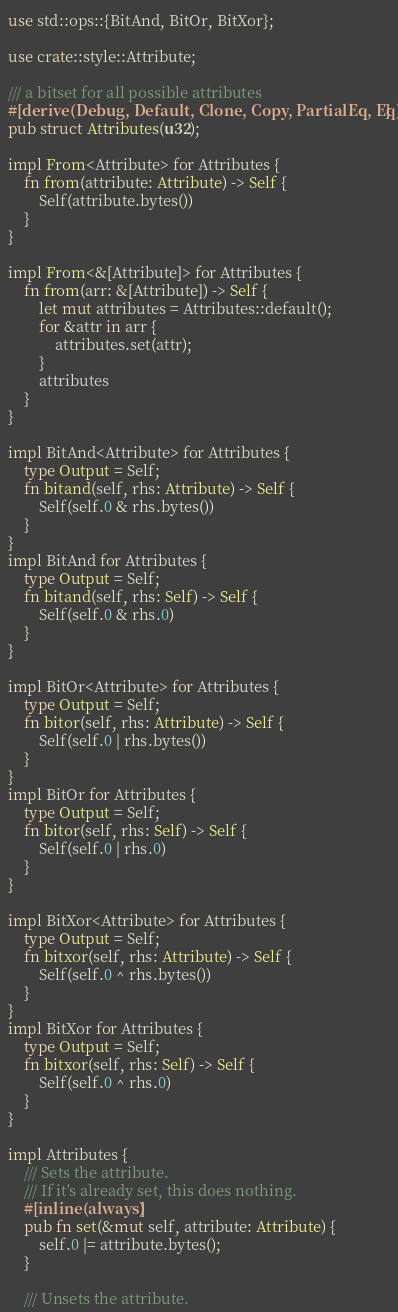<code> <loc_0><loc_0><loc_500><loc_500><_Rust_>use std::ops::{BitAnd, BitOr, BitXor};

use crate::style::Attribute;

/// a bitset for all possible attributes
#[derive(Debug, Default, Clone, Copy, PartialEq, Eq)]
pub struct Attributes(u32);

impl From<Attribute> for Attributes {
    fn from(attribute: Attribute) -> Self {
        Self(attribute.bytes())
    }
}

impl From<&[Attribute]> for Attributes {
    fn from(arr: &[Attribute]) -> Self {
        let mut attributes = Attributes::default();
        for &attr in arr {
            attributes.set(attr);
        }
        attributes
    }
}

impl BitAnd<Attribute> for Attributes {
    type Output = Self;
    fn bitand(self, rhs: Attribute) -> Self {
        Self(self.0 & rhs.bytes())
    }
}
impl BitAnd for Attributes {
    type Output = Self;
    fn bitand(self, rhs: Self) -> Self {
        Self(self.0 & rhs.0)
    }
}

impl BitOr<Attribute> for Attributes {
    type Output = Self;
    fn bitor(self, rhs: Attribute) -> Self {
        Self(self.0 | rhs.bytes())
    }
}
impl BitOr for Attributes {
    type Output = Self;
    fn bitor(self, rhs: Self) -> Self {
        Self(self.0 | rhs.0)
    }
}

impl BitXor<Attribute> for Attributes {
    type Output = Self;
    fn bitxor(self, rhs: Attribute) -> Self {
        Self(self.0 ^ rhs.bytes())
    }
}
impl BitXor for Attributes {
    type Output = Self;
    fn bitxor(self, rhs: Self) -> Self {
        Self(self.0 ^ rhs.0)
    }
}

impl Attributes {
    /// Sets the attribute.
    /// If it's already set, this does nothing.
    #[inline(always)]
    pub fn set(&mut self, attribute: Attribute) {
        self.0 |= attribute.bytes();
    }

    /// Unsets the attribute.</code> 